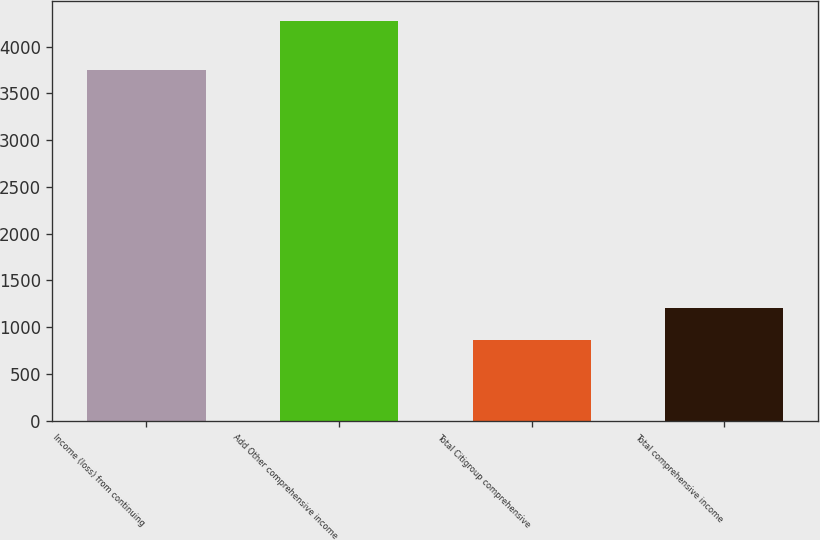<chart> <loc_0><loc_0><loc_500><loc_500><bar_chart><fcel>Income (loss) from continuing<fcel>Add Other comprehensive income<fcel>Total Citigroup comprehensive<fcel>Total comprehensive income<nl><fcel>3752.1<fcel>4277<fcel>866<fcel>1207.1<nl></chart> 